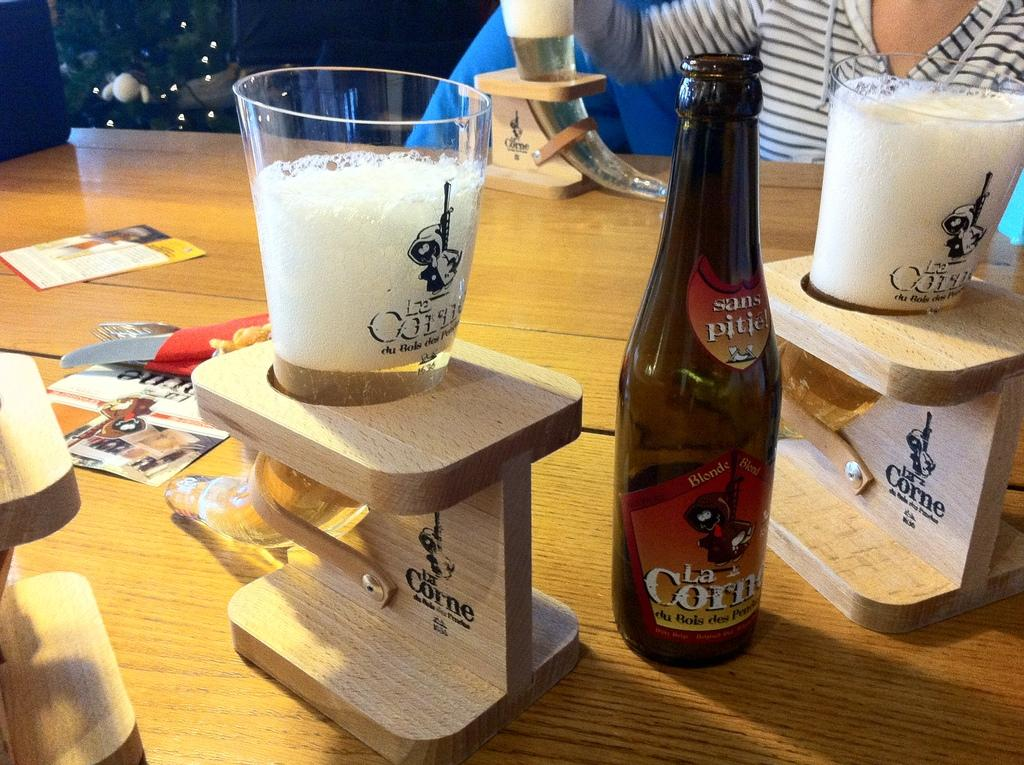<image>
Present a compact description of the photo's key features. many horned shaped glasses and one bottle of La Corne on a table 